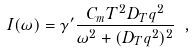<formula> <loc_0><loc_0><loc_500><loc_500>I ( \omega ) = \gamma ^ { \prime } \frac { C _ { m } T ^ { 2 } D _ { T } q ^ { 2 } } { \omega ^ { 2 } + ( D _ { T } q ^ { 2 } ) ^ { 2 } } \ ,</formula> 